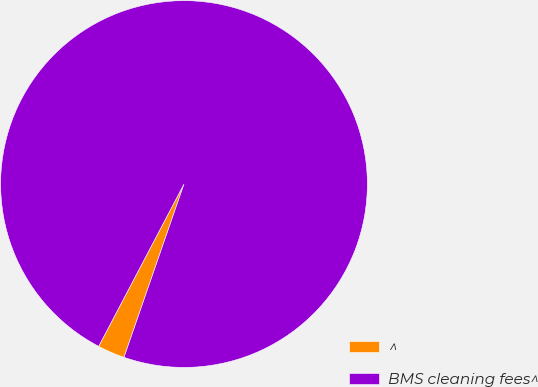Convert chart. <chart><loc_0><loc_0><loc_500><loc_500><pie_chart><fcel>^<fcel>BMS cleaning fees^<nl><fcel>2.4%<fcel>97.6%<nl></chart> 